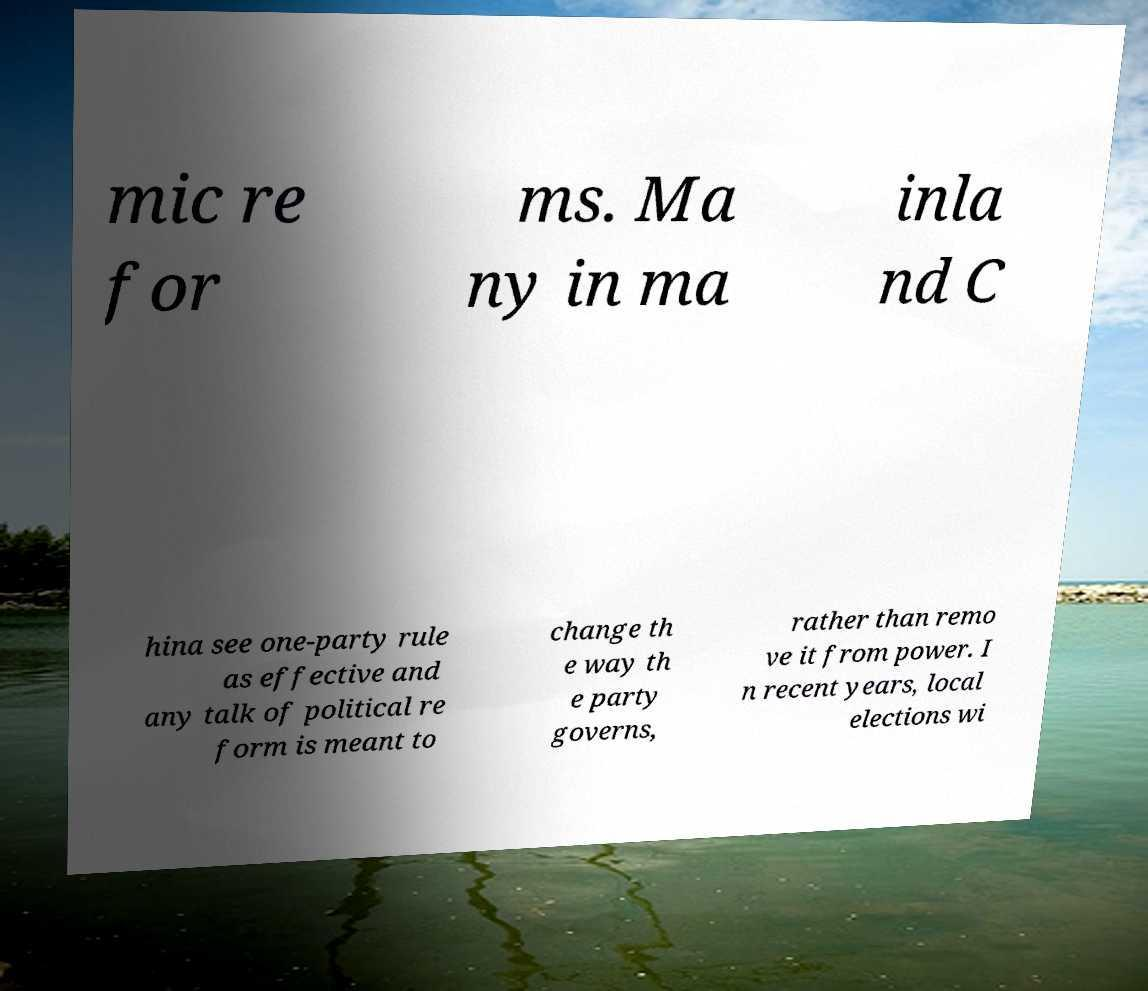Please read and relay the text visible in this image. What does it say? mic re for ms. Ma ny in ma inla nd C hina see one-party rule as effective and any talk of political re form is meant to change th e way th e party governs, rather than remo ve it from power. I n recent years, local elections wi 